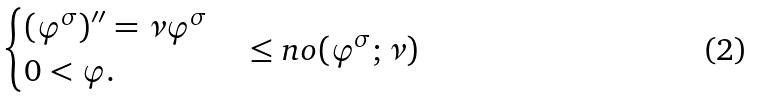Convert formula to latex. <formula><loc_0><loc_0><loc_500><loc_500>\begin{cases} ( \varphi ^ { \sigma } ) ^ { \prime \prime } = \nu \varphi ^ { \sigma } \\ 0 < \varphi . \end{cases} \leq n o ( \varphi ^ { \sigma } ; \nu )</formula> 